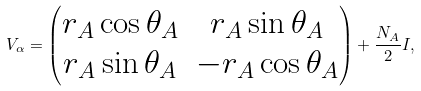Convert formula to latex. <formula><loc_0><loc_0><loc_500><loc_500>V _ { \alpha } = \begin{pmatrix} r _ { A } \cos \theta _ { A } & r _ { A } \sin \theta _ { A } \\ r _ { A } \sin \theta _ { A } & - r _ { A } \cos \theta _ { A } \end{pmatrix} + \frac { N _ { A } } { 2 } I ,</formula> 